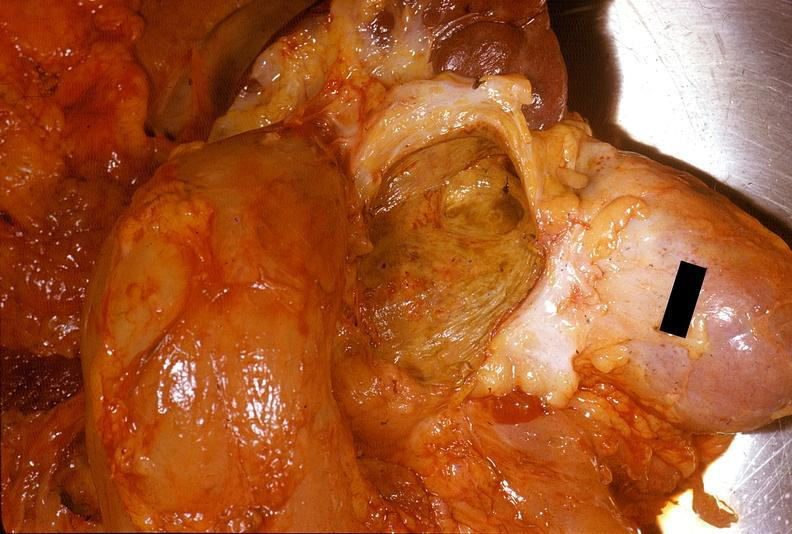what does this image show?
Answer the question using a single word or phrase. Chronic pancreatitis with cyst formation 